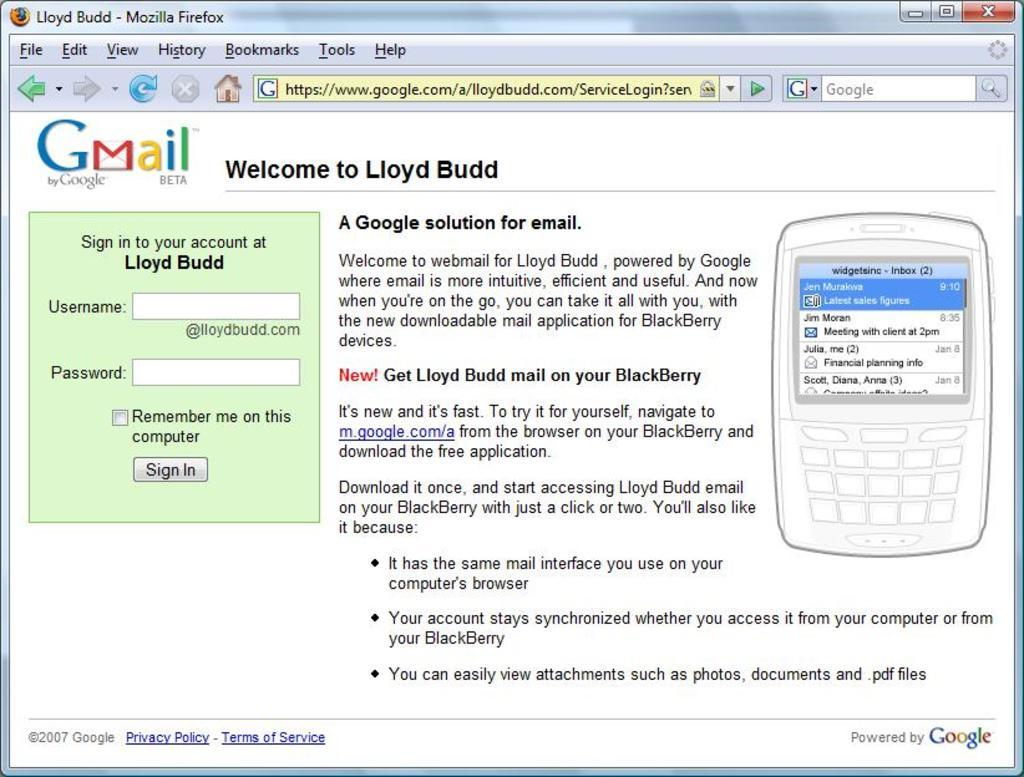<image>
Share a concise interpretation of the image provided. A fire fox login page to lloy budd gmail. 